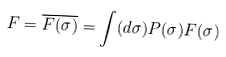Convert formula to latex. <formula><loc_0><loc_0><loc_500><loc_500>F = \overline { F ( \sigma ) } = \int ( d \sigma ) P ( \sigma ) F ( \sigma )</formula> 